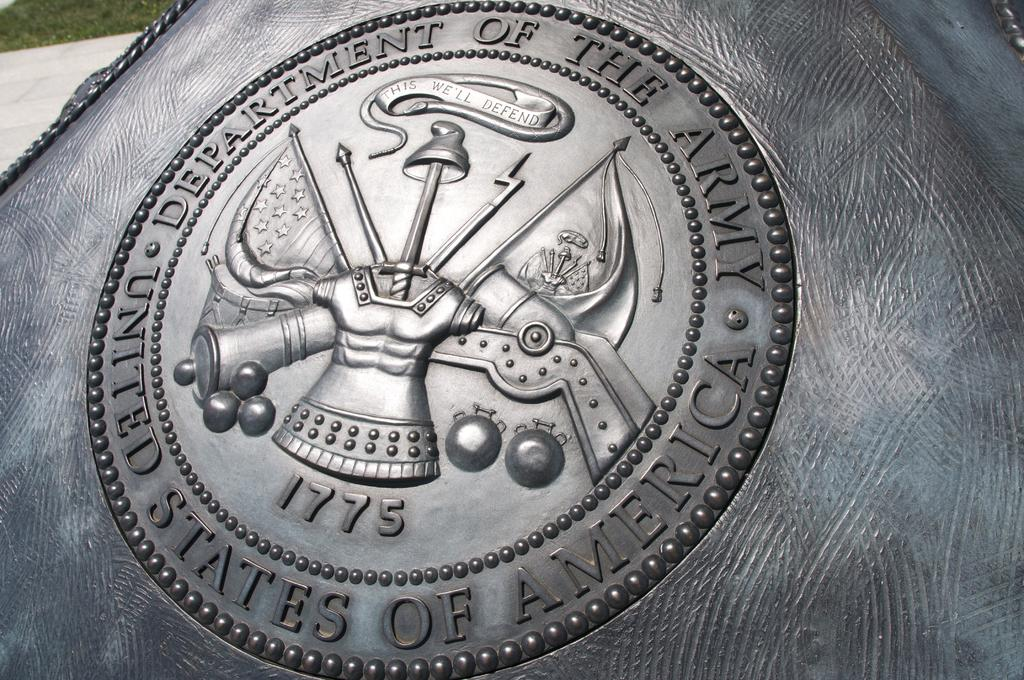<image>
Present a compact description of the photo's key features. silver coin or plaque that s says department of the army 